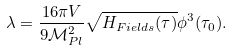Convert formula to latex. <formula><loc_0><loc_0><loc_500><loc_500>\lambda = \frac { 1 6 \pi V } { 9 \mathcal { M } _ { P l } ^ { 2 } } \sqrt { H _ { F i e l d s } ( \tau ) } \phi ^ { 3 } ( \tau _ { 0 } ) .</formula> 